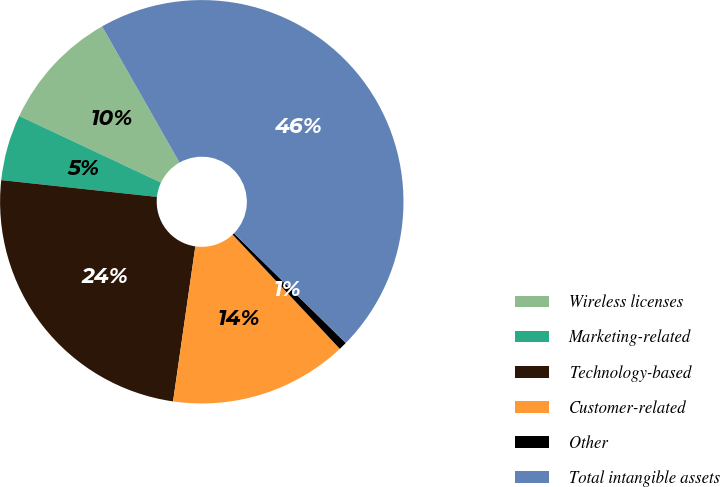Convert chart to OTSL. <chart><loc_0><loc_0><loc_500><loc_500><pie_chart><fcel>Wireless licenses<fcel>Marketing-related<fcel>Technology-based<fcel>Customer-related<fcel>Other<fcel>Total intangible assets<nl><fcel>9.78%<fcel>5.28%<fcel>24.44%<fcel>14.27%<fcel>0.66%<fcel>45.57%<nl></chart> 